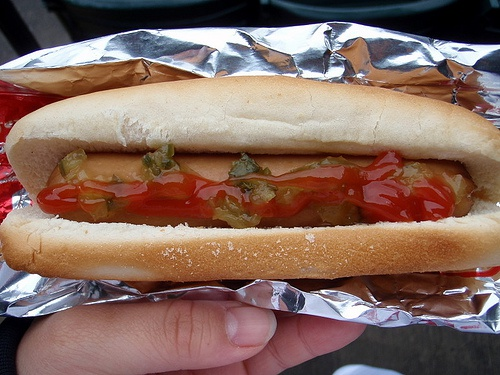Describe the objects in this image and their specific colors. I can see hot dog in black, maroon, brown, and tan tones and people in black, brown, maroon, and gray tones in this image. 